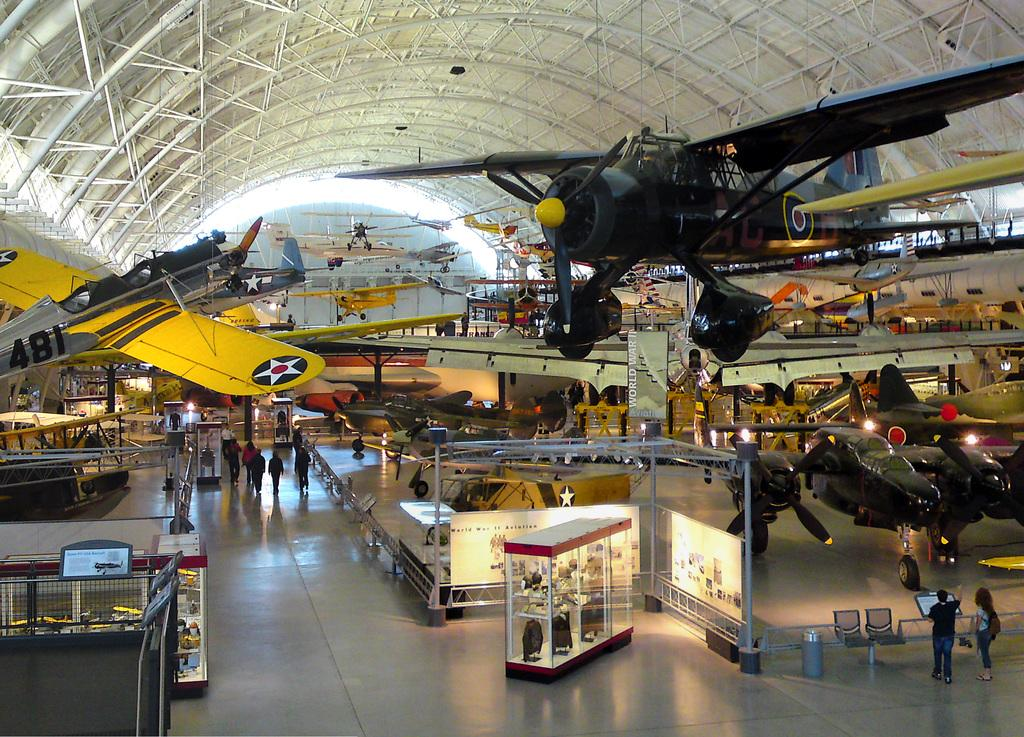<image>
Offer a succinct explanation of the picture presented. Plane 481 is one of many on display here. 